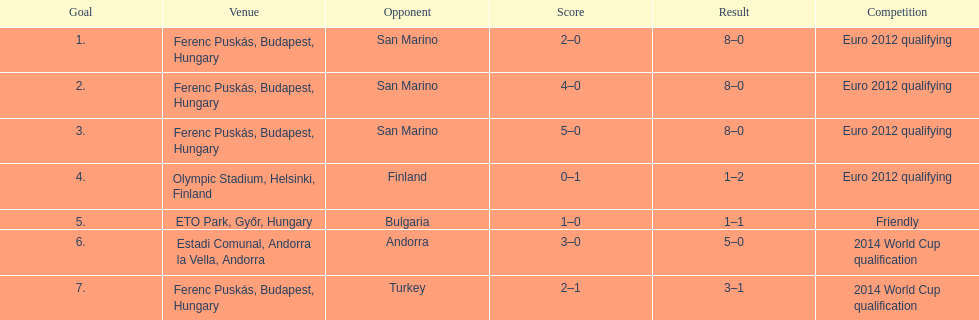How many consecutive games were goals were against san marino? 3. 